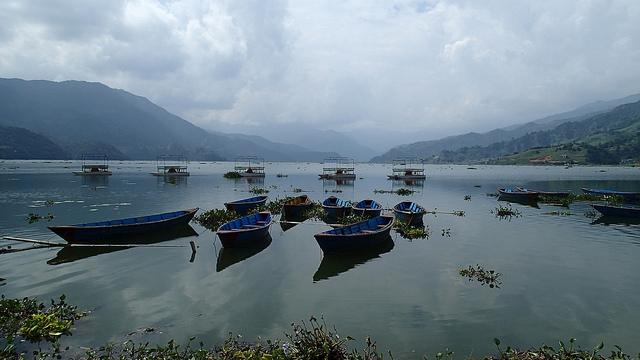How is the visibility?
Give a very brief answer. Clear. How are the boats staying in place?
Concise answer only. Anchor. How many boats are at the dock?
Quick response, please. 0. Are these rowboats?
Give a very brief answer. Yes. What color are the insides of the boats?
Answer briefly. Blue. 